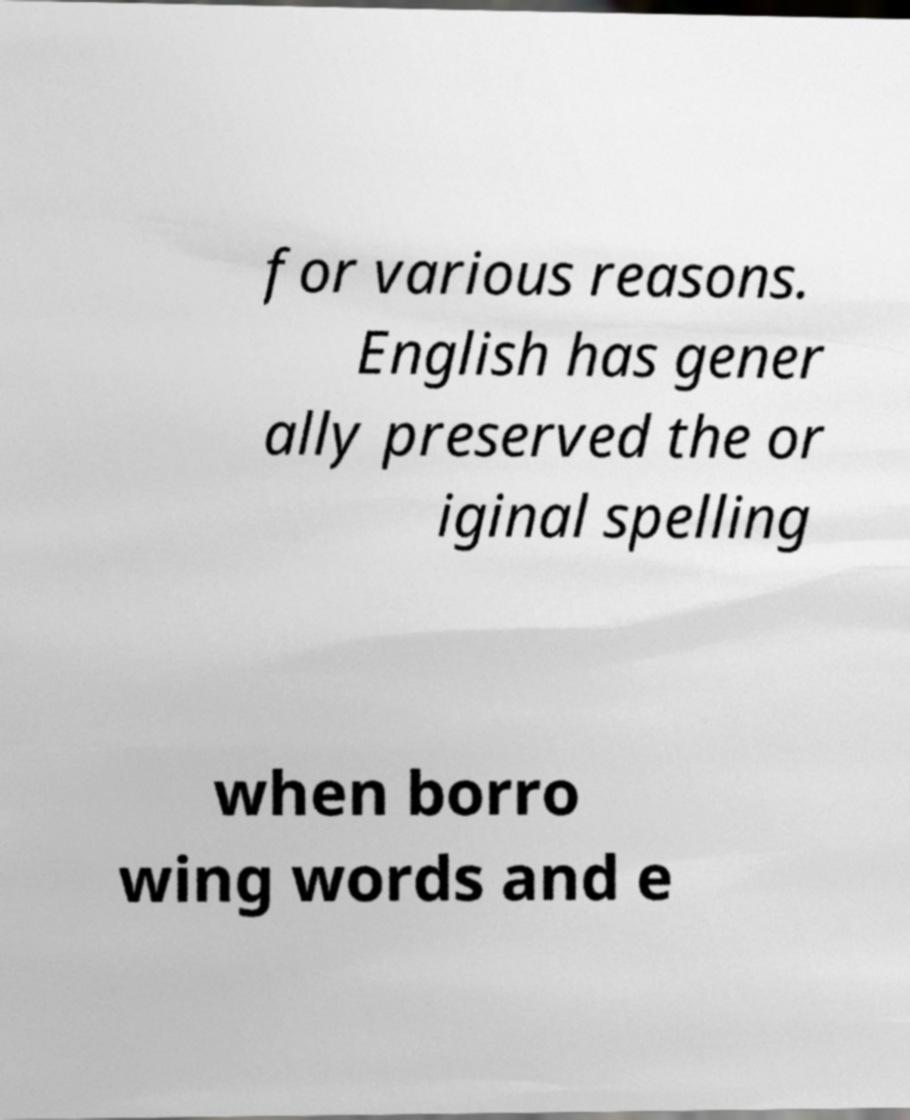Please identify and transcribe the text found in this image. for various reasons. English has gener ally preserved the or iginal spelling when borro wing words and e 